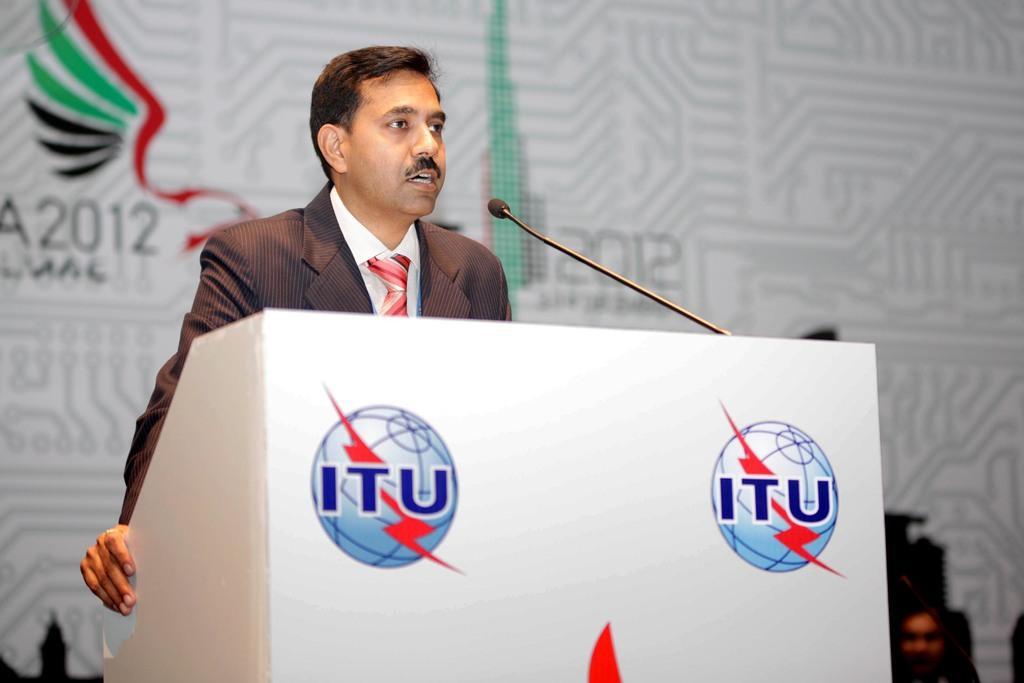Could you give a brief overview of what you see in this image? In the center of this picture we can see a man wearing suit and standing behind a podium and we can see a microphone and we can see the text and some pictures on the podium. In the background we can see the text and the numbers on a white color banner and we can see a person and some other objects. 